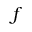Convert formula to latex. <formula><loc_0><loc_0><loc_500><loc_500>f</formula> 